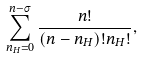<formula> <loc_0><loc_0><loc_500><loc_500>\sum _ { n _ { H } = 0 } ^ { n - \sigma } \frac { n ! } { ( n - n _ { H } ) ! n _ { H } ! } ,</formula> 